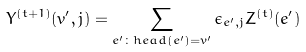Convert formula to latex. <formula><loc_0><loc_0><loc_500><loc_500>Y ^ { ( t + 1 ) } ( v ^ { \prime } , j ) = \sum _ { e ^ { \prime } \colon { h e a d } ( e ^ { \prime } ) = v ^ { \prime } } \epsilon _ { e ^ { \prime } , j } Z ^ { ( t ) } ( e ^ { \prime } )</formula> 